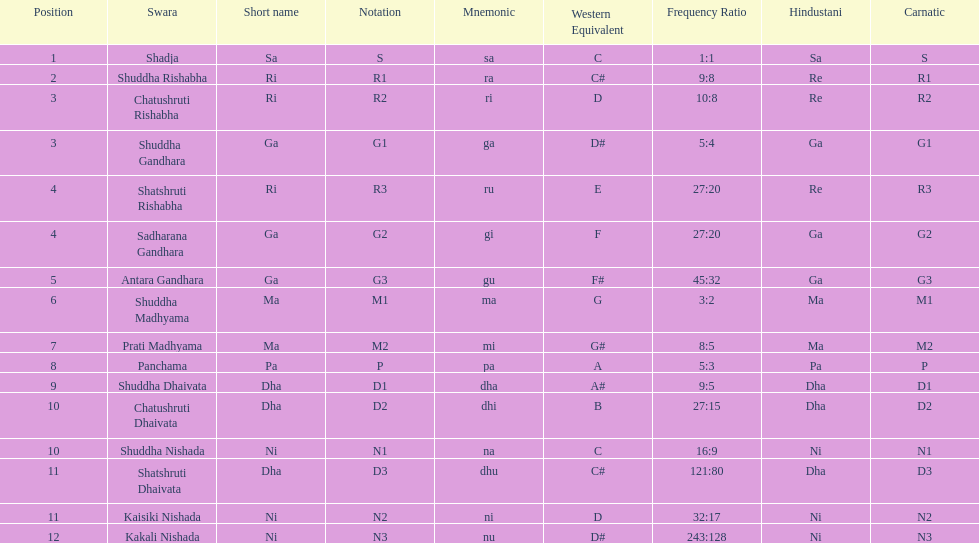Would you be able to parse every entry in this table? {'header': ['Position', 'Swara', 'Short name', 'Notation', 'Mnemonic', 'Western Equivalent', 'Frequency Ratio', 'Hindustani', 'Carnatic'], 'rows': [['1', 'Shadja', 'Sa', 'S', 'sa', 'C', '1:1', 'Sa', 'S'], ['2', 'Shuddha Rishabha', 'Ri', 'R1', 'ra', 'C#', '9:8', 'Re', 'R1'], ['3', 'Chatushruti Rishabha', 'Ri', 'R2', 'ri', 'D', '10:8', 'Re', 'R2'], ['3', 'Shuddha Gandhara', 'Ga', 'G1', 'ga', 'D#', '5:4', 'Ga', 'G1'], ['4', 'Shatshruti Rishabha', 'Ri', 'R3', 'ru', 'E', '27:20', 'Re', 'R3'], ['4', 'Sadharana Gandhara', 'Ga', 'G2', 'gi', 'F', '27:20', 'Ga', 'G2'], ['5', 'Antara Gandhara', 'Ga', 'G3', 'gu', 'F#', '45:32', 'Ga', 'G3'], ['6', 'Shuddha Madhyama', 'Ma', 'M1', 'ma', 'G', '3:2', 'Ma', 'M1'], ['7', 'Prati Madhyama', 'Ma', 'M2', 'mi', 'G#', '8:5', 'Ma', 'M2'], ['8', 'Panchama', 'Pa', 'P', 'pa', 'A', '5:3', 'Pa', 'P'], ['9', 'Shuddha Dhaivata', 'Dha', 'D1', 'dha', 'A#', '9:5', 'Dha', 'D1'], ['10', 'Chatushruti Dhaivata', 'Dha', 'D2', 'dhi', 'B', '27:15', 'Dha', 'D2'], ['10', 'Shuddha Nishada', 'Ni', 'N1', 'na', 'C', '16:9', 'Ni', 'N1'], ['11', 'Shatshruti Dhaivata', 'Dha', 'D3', 'dhu', 'C#', '121:80', 'Dha', 'D3'], ['11', 'Kaisiki Nishada', 'Ni', 'N2', 'ni', 'D', '32:17', 'Ni', 'N2'], ['12', 'Kakali Nishada', 'Ni', 'N3', 'nu', 'D#', '243:128', 'Ni', 'N3']]} What is the total number of positions listed? 16. 